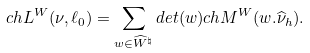<formula> <loc_0><loc_0><loc_500><loc_500>c h L ^ { W } ( \nu , \ell _ { 0 } ) = \sum _ { w \in \widehat { W } ^ { \natural } } d e t ( w ) c h M ^ { W } ( w . \widehat { \nu } _ { h } ) .</formula> 